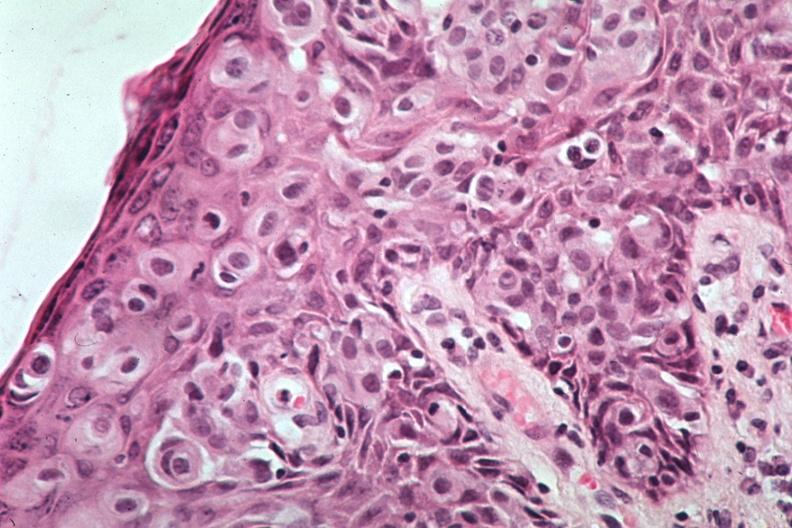what is this image of pagets disease?
Answer the question using a single word or phrase. A quite excellent example 